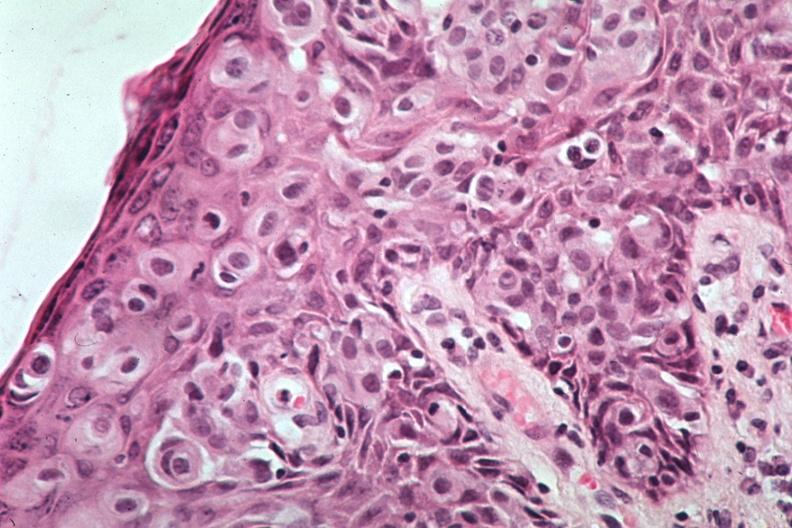what is this image of pagets disease?
Answer the question using a single word or phrase. A quite excellent example 